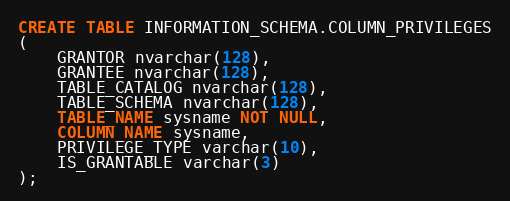<code> <loc_0><loc_0><loc_500><loc_500><_SQL_>CREATE TABLE INFORMATION_SCHEMA.COLUMN_PRIVILEGES
(
    GRANTOR nvarchar(128),
    GRANTEE nvarchar(128),
    TABLE_CATALOG nvarchar(128),
    TABLE_SCHEMA nvarchar(128),
    TABLE_NAME sysname NOT NULL,
    COLUMN_NAME sysname,
    PRIVILEGE_TYPE varchar(10),
    IS_GRANTABLE varchar(3)
);</code> 